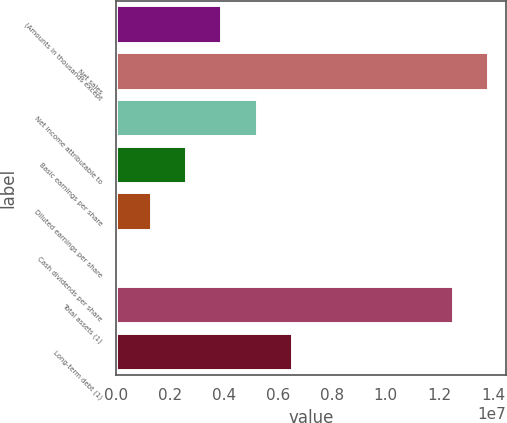<chart> <loc_0><loc_0><loc_500><loc_500><bar_chart><fcel>(Amounts in thousands except<fcel>Net sales<fcel>Net income attributable to<fcel>Basic earnings per share<fcel>Diluted earnings per share<fcel>Cash dividends per share<fcel>Total assets (1)<fcel>Long-term debt (1)<nl><fcel>3.90471e+06<fcel>1.37925e+07<fcel>5.20628e+06<fcel>2.60314e+06<fcel>1.30157e+06<fcel>1.7<fcel>1.2491e+07<fcel>6.50785e+06<nl></chart> 